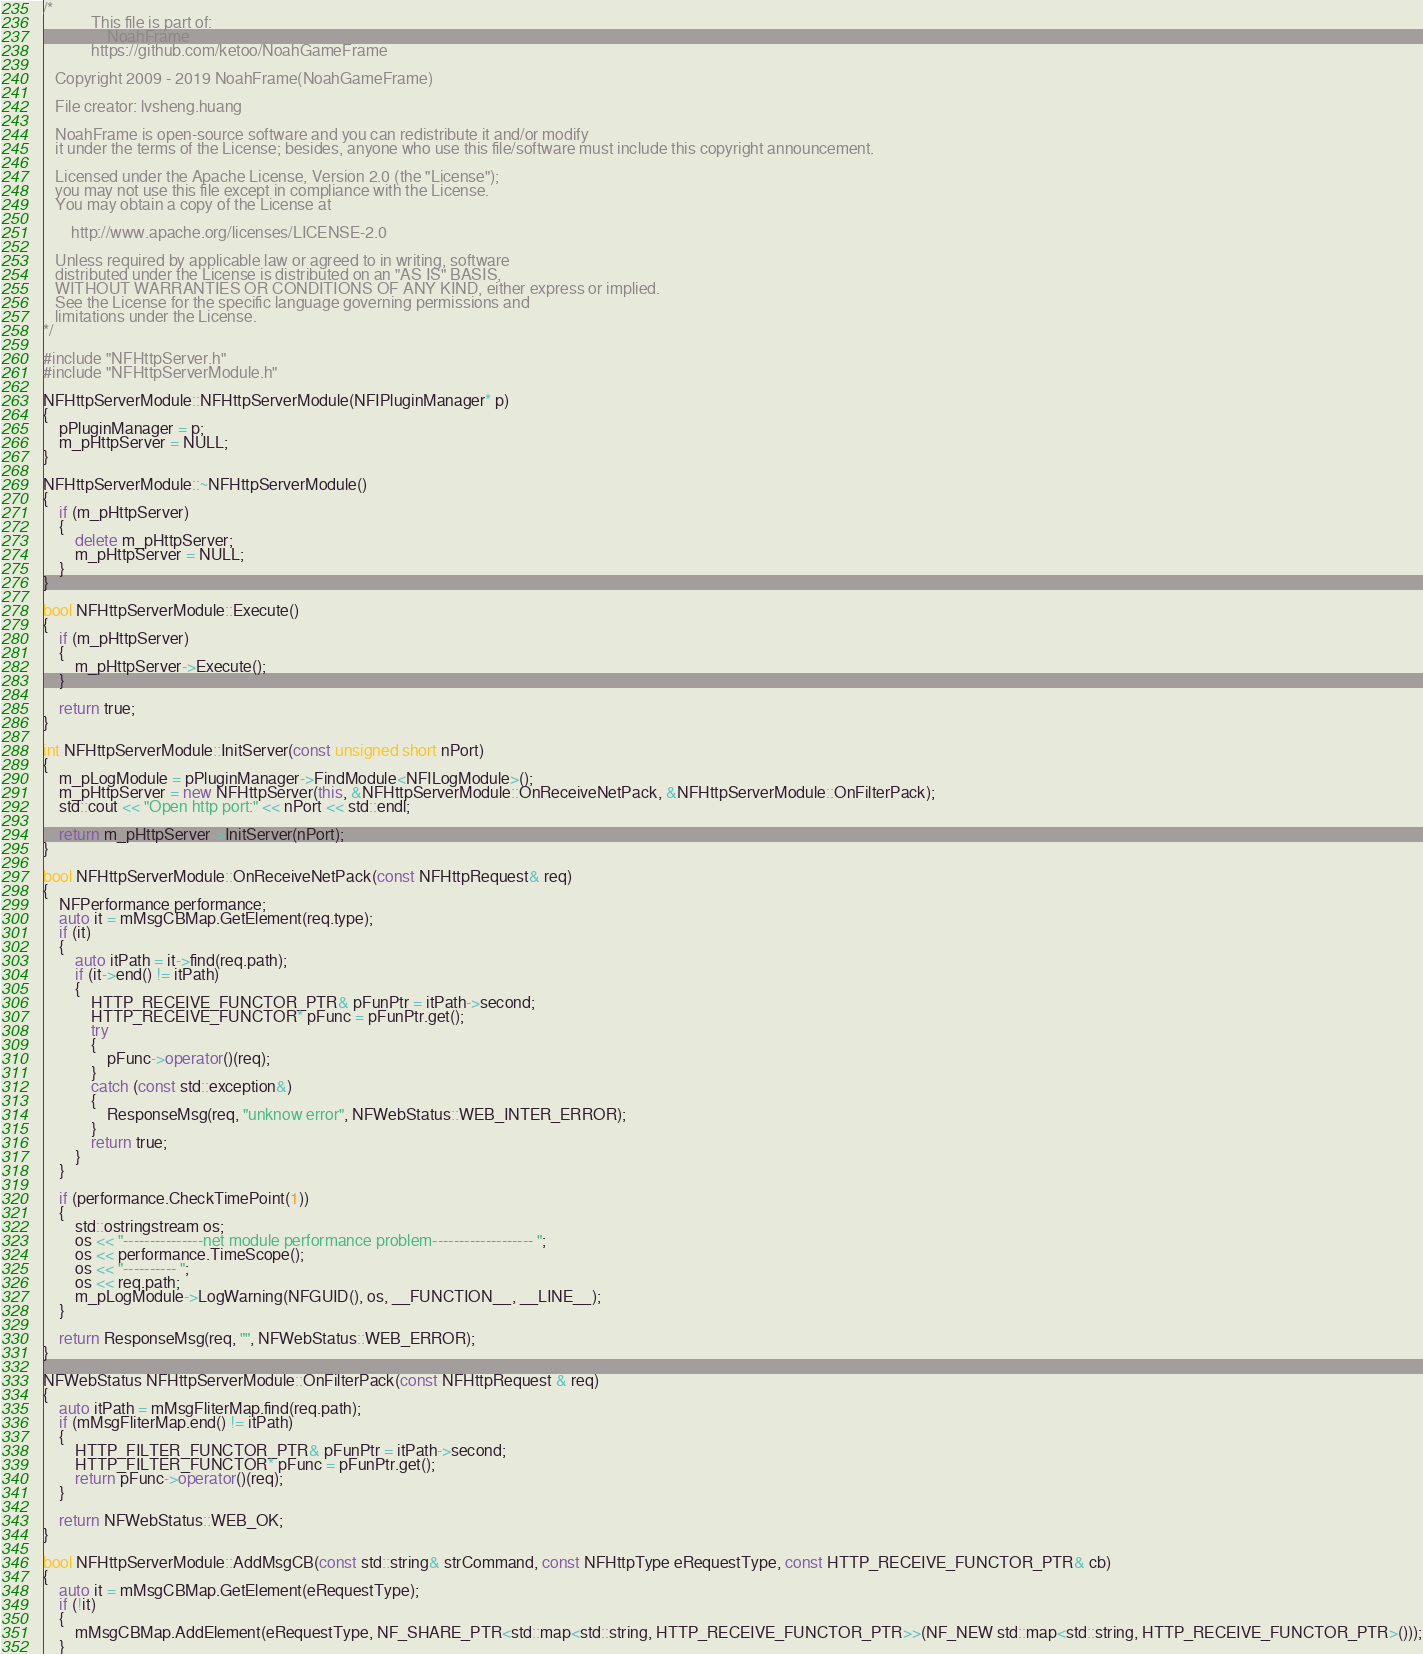<code> <loc_0><loc_0><loc_500><loc_500><_C++_>/*
            This file is part of: 
                NoahFrame
            https://github.com/ketoo/NoahGameFrame

   Copyright 2009 - 2019 NoahFrame(NoahGameFrame)

   File creator: lvsheng.huang
   
   NoahFrame is open-source software and you can redistribute it and/or modify
   it under the terms of the License; besides, anyone who use this file/software must include this copyright announcement.

   Licensed under the Apache License, Version 2.0 (the "License");
   you may not use this file except in compliance with the License.
   You may obtain a copy of the License at

       http://www.apache.org/licenses/LICENSE-2.0

   Unless required by applicable law or agreed to in writing, software
   distributed under the License is distributed on an "AS IS" BASIS,
   WITHOUT WARRANTIES OR CONDITIONS OF ANY KIND, either express or implied.
   See the License for the specific language governing permissions and
   limitations under the License.
*/

#include "NFHttpServer.h"
#include "NFHttpServerModule.h"

NFHttpServerModule::NFHttpServerModule(NFIPluginManager* p)
{
    pPluginManager = p;
    m_pHttpServer = NULL;
}

NFHttpServerModule::~NFHttpServerModule()
{
    if (m_pHttpServer)
    {
        delete m_pHttpServer;
        m_pHttpServer = NULL;
    }
}

bool NFHttpServerModule::Execute()
{
    if (m_pHttpServer)
    {
        m_pHttpServer->Execute();
    }

    return true;
}

int NFHttpServerModule::InitServer(const unsigned short nPort)
{
	m_pLogModule = pPluginManager->FindModule<NFILogModule>();
	m_pHttpServer = new NFHttpServer(this, &NFHttpServerModule::OnReceiveNetPack, &NFHttpServerModule::OnFilterPack);
    std::cout << "Open http port:" << nPort << std::endl;

    return m_pHttpServer->InitServer(nPort);
}

bool NFHttpServerModule::OnReceiveNetPack(const NFHttpRequest& req)
{
	NFPerformance performance;
	auto it = mMsgCBMap.GetElement(req.type);
	if (it)
	{
		auto itPath = it->find(req.path);
		if (it->end() != itPath)
		{
			HTTP_RECEIVE_FUNCTOR_PTR& pFunPtr = itPath->second;
			HTTP_RECEIVE_FUNCTOR* pFunc = pFunPtr.get();
			try
			{
				pFunc->operator()(req);
			}
			catch (const std::exception&)
			{
				ResponseMsg(req, "unknow error", NFWebStatus::WEB_INTER_ERROR);
			}
			return true;
		}
	}

	if (performance.CheckTimePoint(1))
	{
		std::ostringstream os;
		os << "---------------net module performance problem------------------- ";
		os << performance.TimeScope();
		os << "---------- ";
		os << req.path;
		m_pLogModule->LogWarning(NFGUID(), os, __FUNCTION__, __LINE__);
	}

	return ResponseMsg(req, "", NFWebStatus::WEB_ERROR);
}

NFWebStatus NFHttpServerModule::OnFilterPack(const NFHttpRequest & req)
{
	auto itPath = mMsgFliterMap.find(req.path);
	if (mMsgFliterMap.end() != itPath)
	{
		HTTP_FILTER_FUNCTOR_PTR& pFunPtr = itPath->second;
		HTTP_FILTER_FUNCTOR* pFunc = pFunPtr.get();
		return pFunc->operator()(req);
	}

	return NFWebStatus::WEB_OK;
}

bool NFHttpServerModule::AddMsgCB(const std::string& strCommand, const NFHttpType eRequestType, const HTTP_RECEIVE_FUNCTOR_PTR& cb)
{
	auto it = mMsgCBMap.GetElement(eRequestType);
	if (!it)
	{
		mMsgCBMap.AddElement(eRequestType, NF_SHARE_PTR<std::map<std::string, HTTP_RECEIVE_FUNCTOR_PTR>>(NF_NEW std::map<std::string, HTTP_RECEIVE_FUNCTOR_PTR>()));
	}
</code> 